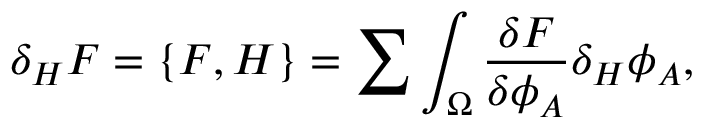<formula> <loc_0><loc_0><loc_500><loc_500>\delta _ { H } F = \{ F , H \} = \sum \int _ { \Omega } { \frac { \delta F } { \delta \phi _ { A } } } \delta _ { H } \phi _ { A } ,</formula> 